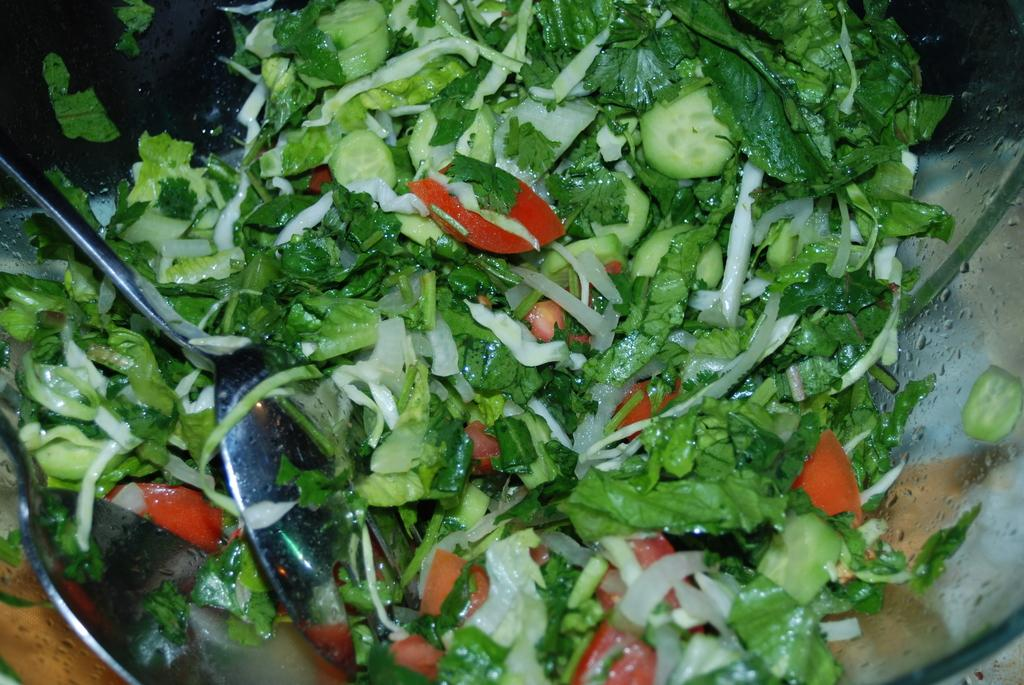What is in the bowl that is visible in the image? The bowl contains food. How many spoons are in the image? There are two spoons in the image. Where are the spoons located in the image? The spoons are on the left side of the image. How many toes can be seen in the image? There are no toes visible in the image. What type of pollution is present in the image? There is no pollution present in the image. 